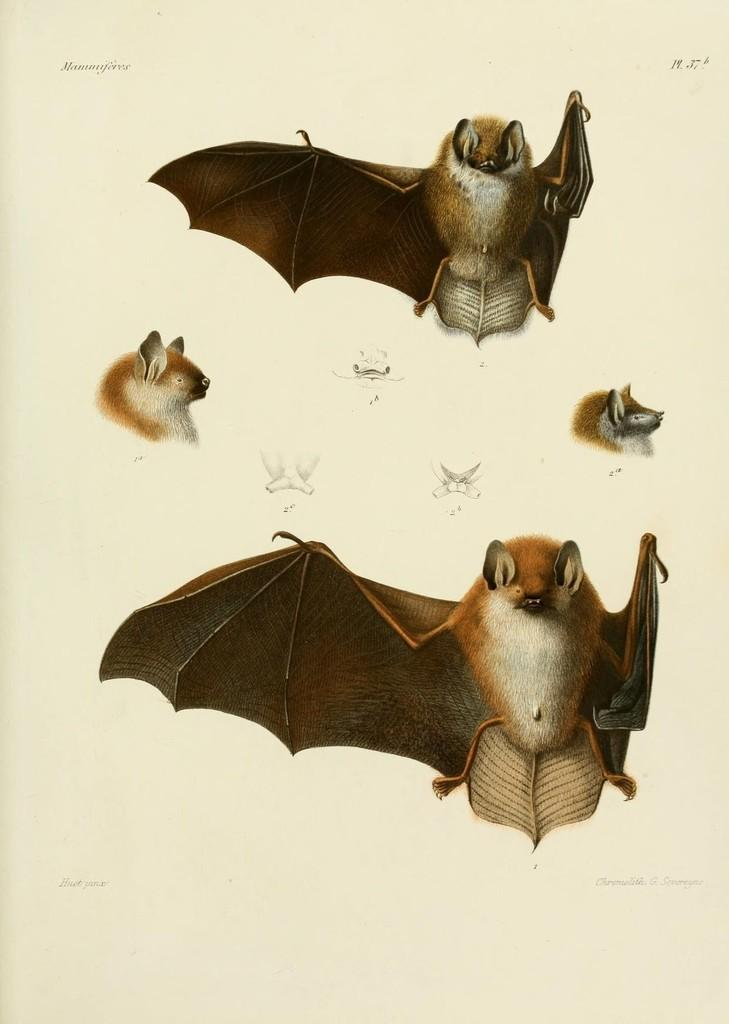What type of animals are in the image? There are bats in the image. What color are the bats in the image? The bats are in brown color. Can you describe the style of the image? The image appears to be a painting. Where is the hose used for watering plants in the image? There is no hose present in the image. What type of ship can be seen sailing in the image? There is no ship present in the image. 